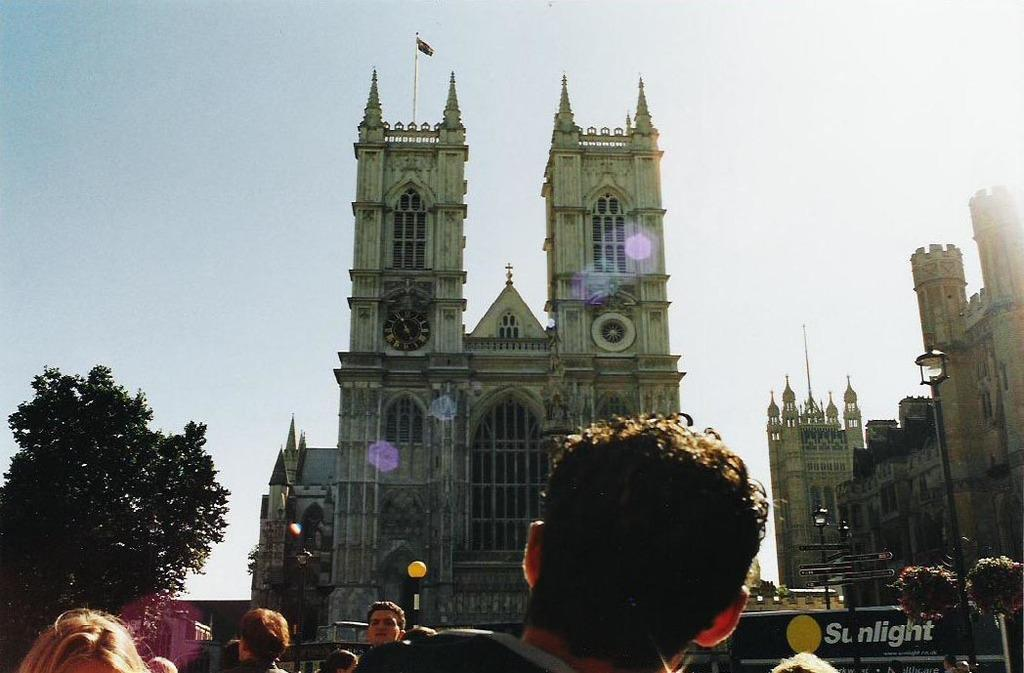Who or what can be seen in the image? There are people visible in the image. What type of structures are present in the image? There are castles and buildings in the image. What type of vegetation is present in the image? Trees are present in the image. What is visible in the background of the image? The sky is visible in the image. Can you tell me how many people are swimming in the image? There is no swimming activity depicted in the image; people are not shown in water. 